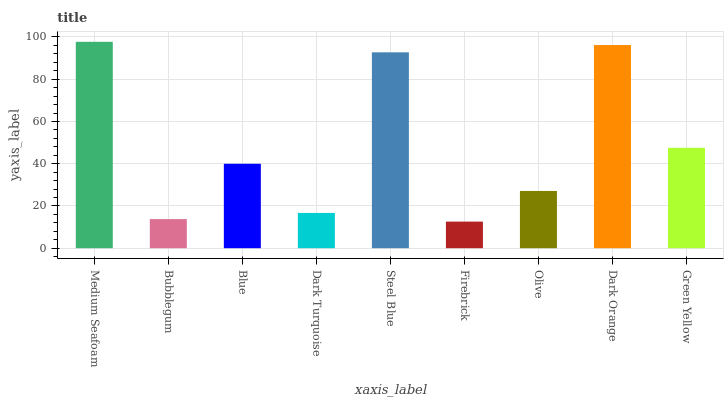Is Firebrick the minimum?
Answer yes or no. Yes. Is Medium Seafoam the maximum?
Answer yes or no. Yes. Is Bubblegum the minimum?
Answer yes or no. No. Is Bubblegum the maximum?
Answer yes or no. No. Is Medium Seafoam greater than Bubblegum?
Answer yes or no. Yes. Is Bubblegum less than Medium Seafoam?
Answer yes or no. Yes. Is Bubblegum greater than Medium Seafoam?
Answer yes or no. No. Is Medium Seafoam less than Bubblegum?
Answer yes or no. No. Is Blue the high median?
Answer yes or no. Yes. Is Blue the low median?
Answer yes or no. Yes. Is Steel Blue the high median?
Answer yes or no. No. Is Firebrick the low median?
Answer yes or no. No. 